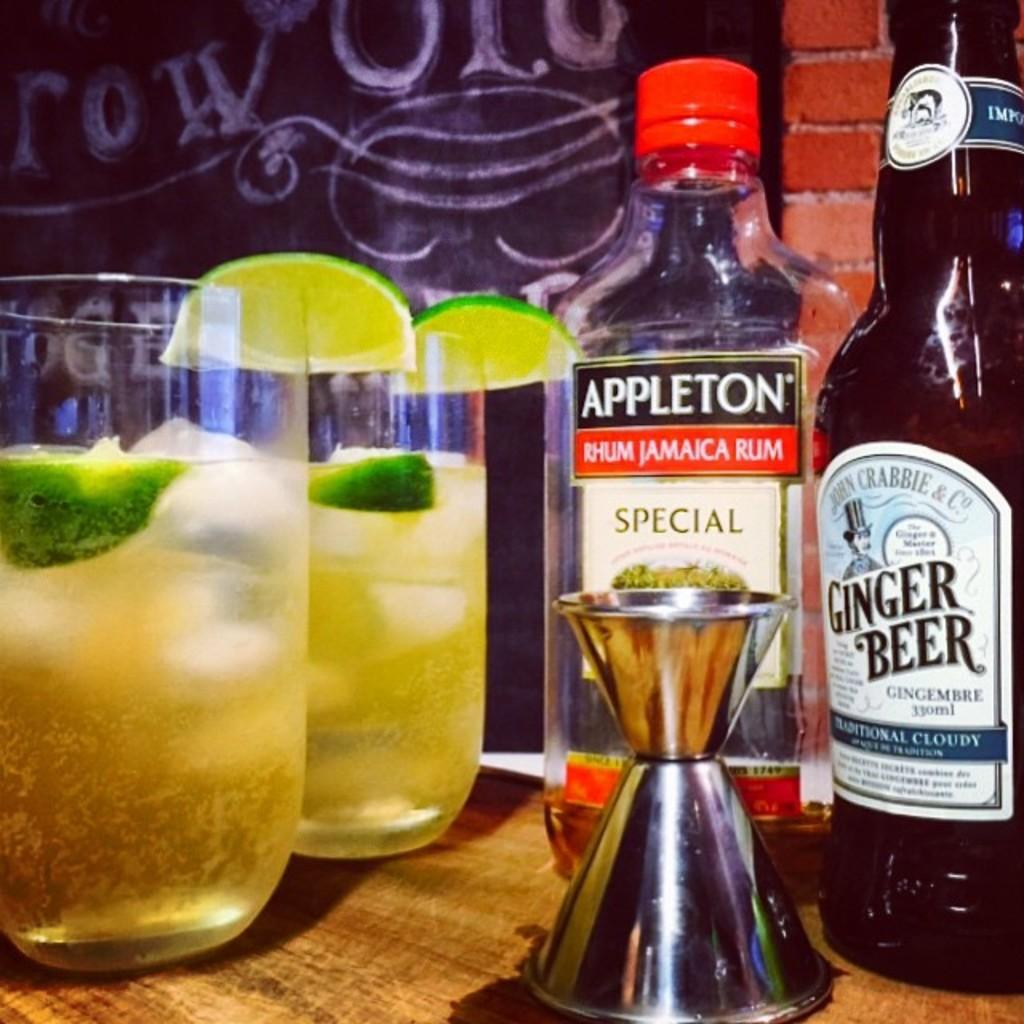What sort of beer is being served?
Offer a very short reply. Ginger beer. What kind of rum is in the bottle?
Keep it short and to the point. Jamaica. 